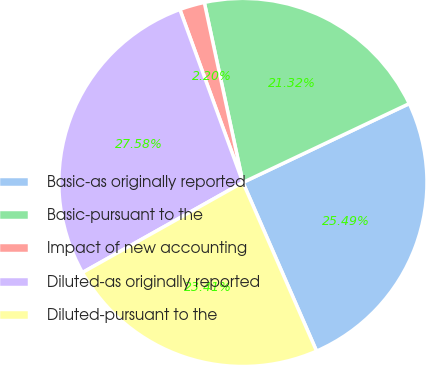<chart> <loc_0><loc_0><loc_500><loc_500><pie_chart><fcel>Basic-as originally reported<fcel>Basic-pursuant to the<fcel>Impact of new accounting<fcel>Diluted-as originally reported<fcel>Diluted-pursuant to the<nl><fcel>25.49%<fcel>21.32%<fcel>2.2%<fcel>27.58%<fcel>23.41%<nl></chart> 